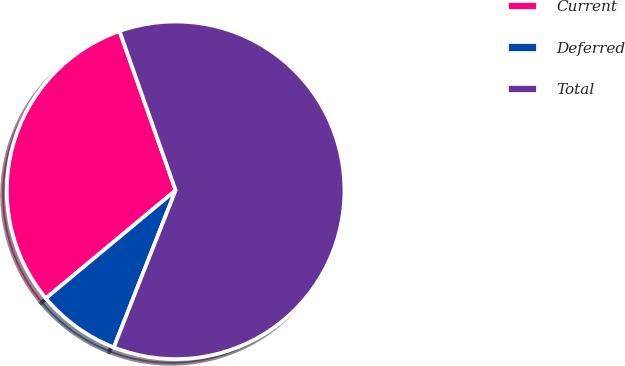Convert chart. <chart><loc_0><loc_0><loc_500><loc_500><pie_chart><fcel>Current<fcel>Deferred<fcel>Total<nl><fcel>30.65%<fcel>7.99%<fcel>61.36%<nl></chart> 